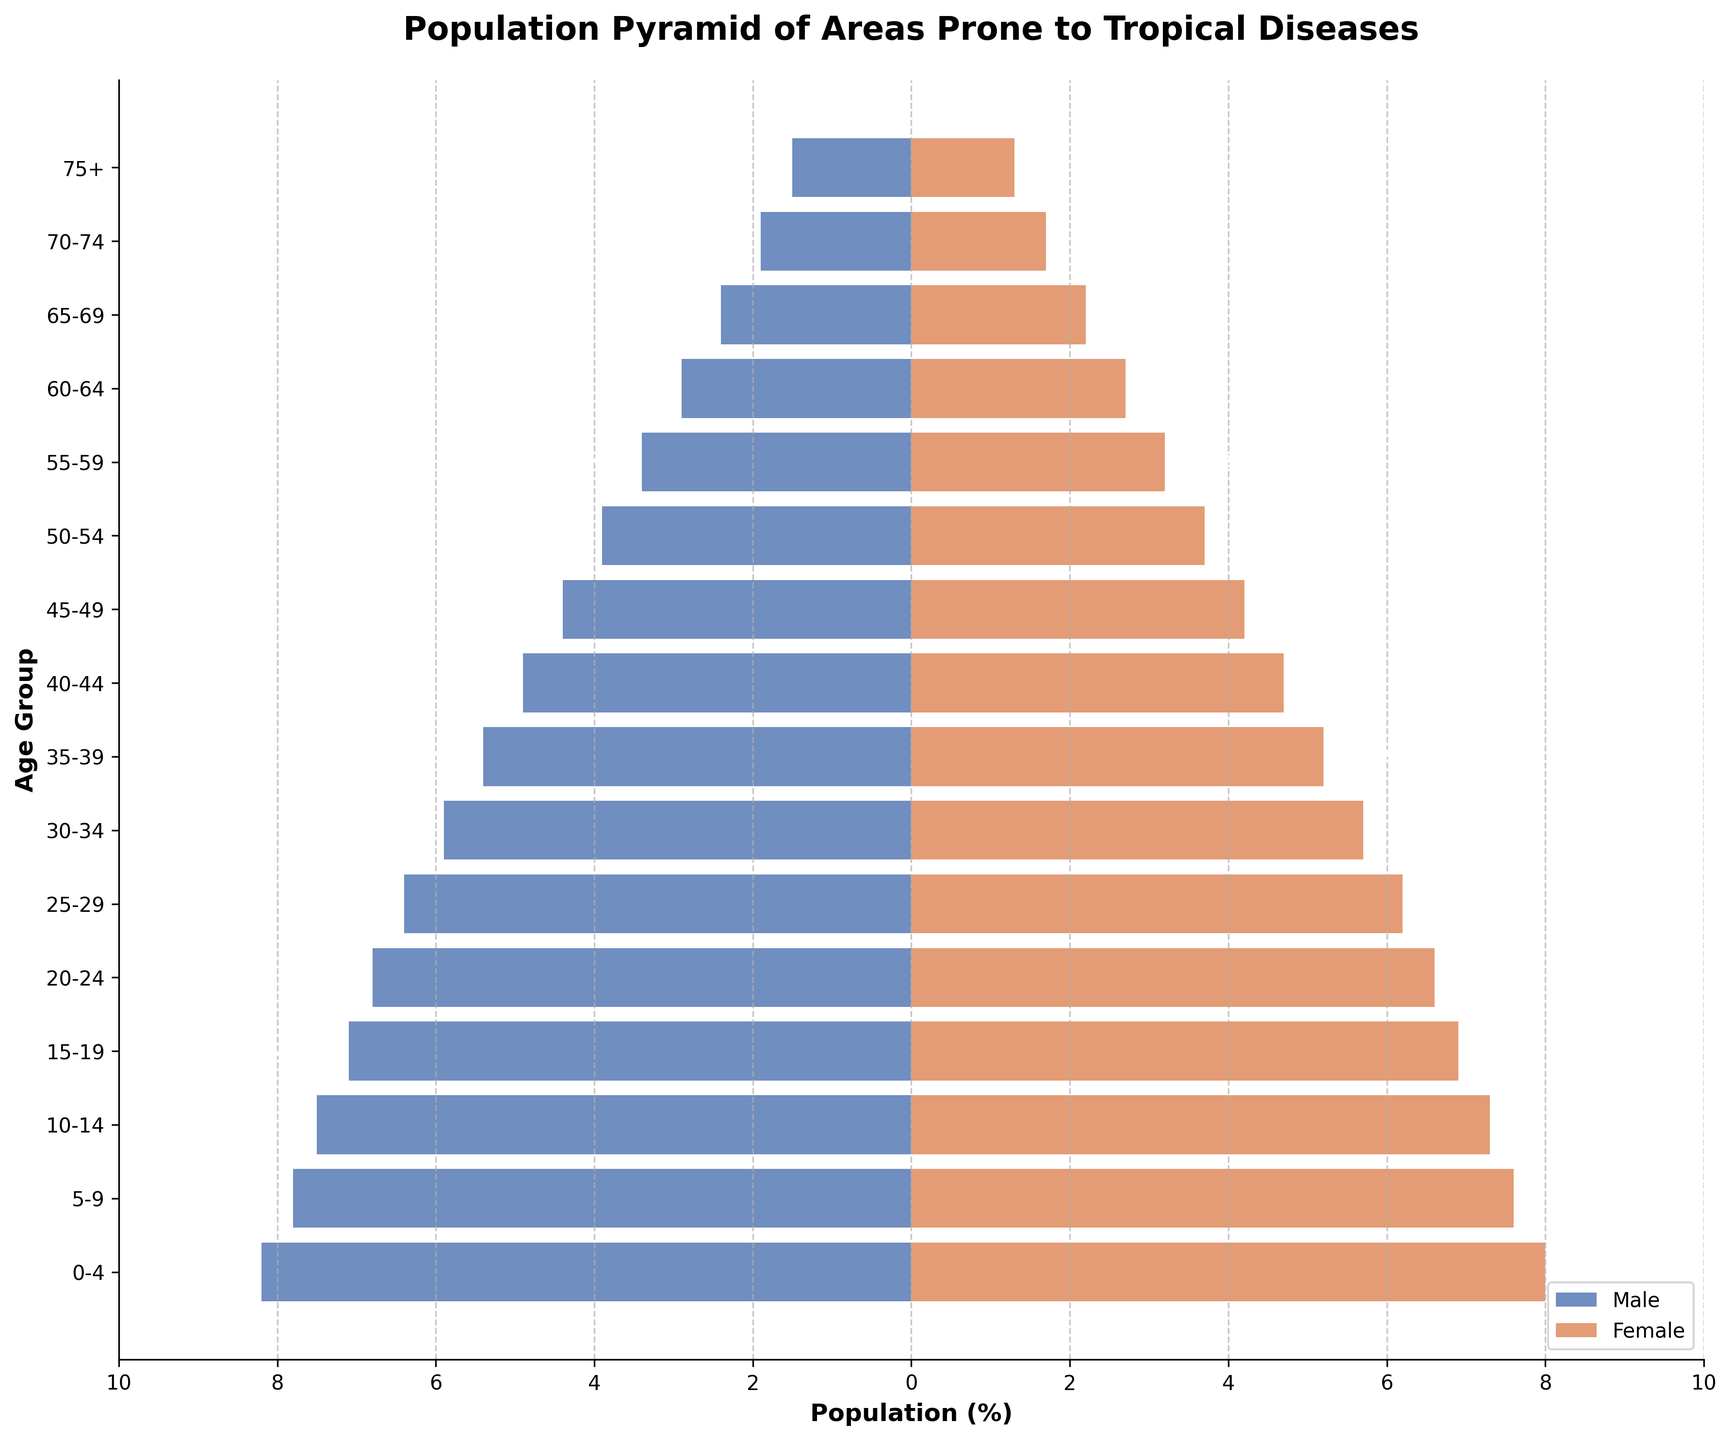What is the title of the figure? The title can be found at the top of the figure. It is usually in a larger and bolder font to stand out. The title of this figure is "Population Pyramid of Areas Prone to Tropical Diseases".
Answer: Population Pyramid of Areas Prone to Tropical Diseases What are the colors representing male and female populations in the plot? The male and female populations are distinguished by different colors. The figure uses blueish color for males and orangish color for females. This is indicated in the legend at the bottom of the plot.
Answer: Blueish for male, Orangish for female Which age group has the highest male population? To determine this, look at the bars extending to the left, representing the male population. The longest bar (i.e., extending the farthest to the left) indicates the highest population. For this pyramid, the age group 0-4 has the highest male population.
Answer: 0-4 Compare the male and female populations in the 20-24 age group. Which gender has a higher population and by how much? The male population can be observed to the left at approximately -6.8%, and the female population on the right at 6.6%. The male population is higher. By difference, 6.8% - 6.6% = 0.2%.
Answer: Male by 0.2% Which age group shows the least difference between male and female populations? To find this, analyze the left and right bars that are closest in length. Calculations might be necessary for different pairs. Age group 75+, where males are at 1.5% and females are at 1.3%, has the smallest difference of 0.2%.
Answer: 75+ What is the combined population percentage of males and females in the 45-49 age group? Find the values for both males (4.4%) and females (4.2%), then add them together: 4.4% + 4.2% = 8.6%.
Answer: 8.6% How does the population of males in the 0-4 age group compare to that in the 70-74 age group? The male population percentage in the 0-4 age group is 8.2%, while in the 70-74 age group it's 1.9%. By subtraction, the 0-4 males have an excess of 8.2% - 1.9% = 6.3%.
Answer: 0-4 age group is higher by 6.3% What trend can you observe in the population distribution from the 0-4 to the 75+ age groups for both males and females? Observe the heights of the bars from youngest to oldest. Both male and female populations show a decreasing trend as age increases, reflecting a pyramid shape where younger age groups are larger than older ones.
Answer: Decreasing trend with age Which gender has a larger population in the age group 55-59? Compare the male and female bars in the 55-59 age group. Males are at -3.4% and females are at 3.2%, so the male population is larger.
Answer: Male What is the percentage difference between the male and female population in the age group 30-34? Observe the bars for both genders in this age group. The male population is 5.9%, and the female is 5.7%. So, the difference is 5.9% - 5.7% = 0.2%.
Answer: 0.2% 